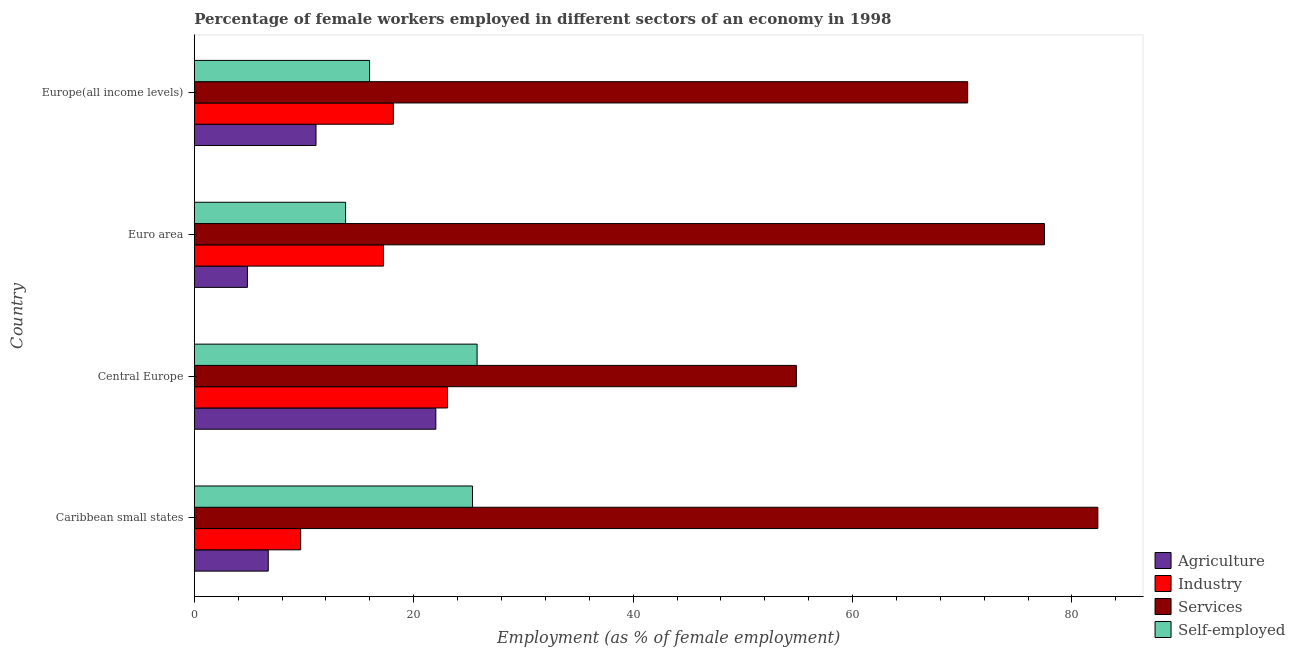How many groups of bars are there?
Provide a short and direct response. 4. How many bars are there on the 1st tick from the bottom?
Offer a very short reply. 4. What is the label of the 2nd group of bars from the top?
Your response must be concise. Euro area. What is the percentage of female workers in services in Euro area?
Your answer should be compact. 77.49. Across all countries, what is the maximum percentage of female workers in services?
Give a very brief answer. 82.36. Across all countries, what is the minimum percentage of female workers in services?
Your answer should be compact. 54.88. In which country was the percentage of female workers in agriculture maximum?
Offer a very short reply. Central Europe. What is the total percentage of female workers in agriculture in the graph?
Your response must be concise. 44.7. What is the difference between the percentage of female workers in industry in Central Europe and that in Europe(all income levels)?
Make the answer very short. 4.94. What is the difference between the percentage of female workers in agriculture in Euro area and the percentage of female workers in industry in Caribbean small states?
Your answer should be compact. -4.86. What is the average percentage of female workers in industry per country?
Your response must be concise. 17.04. What is the difference between the percentage of female workers in industry and percentage of female workers in agriculture in Euro area?
Offer a very short reply. 12.4. What is the ratio of the percentage of female workers in industry in Caribbean small states to that in Europe(all income levels)?
Provide a short and direct response. 0.54. What is the difference between the highest and the second highest percentage of self employed female workers?
Your answer should be compact. 0.42. What is the difference between the highest and the lowest percentage of female workers in agriculture?
Make the answer very short. 17.17. In how many countries, is the percentage of self employed female workers greater than the average percentage of self employed female workers taken over all countries?
Offer a very short reply. 2. Is it the case that in every country, the sum of the percentage of female workers in industry and percentage of self employed female workers is greater than the sum of percentage of female workers in agriculture and percentage of female workers in services?
Give a very brief answer. Yes. What does the 1st bar from the top in Europe(all income levels) represents?
Your response must be concise. Self-employed. What does the 1st bar from the bottom in Central Europe represents?
Give a very brief answer. Agriculture. How many bars are there?
Offer a very short reply. 16. Are the values on the major ticks of X-axis written in scientific E-notation?
Offer a very short reply. No. Where does the legend appear in the graph?
Your answer should be very brief. Bottom right. How many legend labels are there?
Give a very brief answer. 4. How are the legend labels stacked?
Offer a very short reply. Vertical. What is the title of the graph?
Ensure brevity in your answer.  Percentage of female workers employed in different sectors of an economy in 1998. Does "Insurance services" appear as one of the legend labels in the graph?
Ensure brevity in your answer.  No. What is the label or title of the X-axis?
Offer a very short reply. Employment (as % of female employment). What is the Employment (as % of female employment) of Agriculture in Caribbean small states?
Your answer should be very brief. 6.74. What is the Employment (as % of female employment) of Industry in Caribbean small states?
Your response must be concise. 9.7. What is the Employment (as % of female employment) in Services in Caribbean small states?
Provide a short and direct response. 82.36. What is the Employment (as % of female employment) in Self-employed in Caribbean small states?
Provide a short and direct response. 25.36. What is the Employment (as % of female employment) in Agriculture in Central Europe?
Keep it short and to the point. 22.02. What is the Employment (as % of female employment) in Industry in Central Europe?
Your answer should be very brief. 23.09. What is the Employment (as % of female employment) in Services in Central Europe?
Ensure brevity in your answer.  54.88. What is the Employment (as % of female employment) in Self-employed in Central Europe?
Make the answer very short. 25.78. What is the Employment (as % of female employment) of Agriculture in Euro area?
Your answer should be compact. 4.84. What is the Employment (as % of female employment) of Industry in Euro area?
Keep it short and to the point. 17.24. What is the Employment (as % of female employment) of Services in Euro area?
Offer a very short reply. 77.49. What is the Employment (as % of female employment) of Self-employed in Euro area?
Your answer should be compact. 13.79. What is the Employment (as % of female employment) in Agriculture in Europe(all income levels)?
Provide a short and direct response. 11.1. What is the Employment (as % of female employment) in Industry in Europe(all income levels)?
Your response must be concise. 18.14. What is the Employment (as % of female employment) of Services in Europe(all income levels)?
Offer a very short reply. 70.5. What is the Employment (as % of female employment) in Self-employed in Europe(all income levels)?
Offer a terse response. 15.98. Across all countries, what is the maximum Employment (as % of female employment) in Agriculture?
Ensure brevity in your answer.  22.02. Across all countries, what is the maximum Employment (as % of female employment) of Industry?
Your response must be concise. 23.09. Across all countries, what is the maximum Employment (as % of female employment) of Services?
Provide a short and direct response. 82.36. Across all countries, what is the maximum Employment (as % of female employment) of Self-employed?
Your answer should be very brief. 25.78. Across all countries, what is the minimum Employment (as % of female employment) of Agriculture?
Make the answer very short. 4.84. Across all countries, what is the minimum Employment (as % of female employment) in Industry?
Your answer should be compact. 9.7. Across all countries, what is the minimum Employment (as % of female employment) in Services?
Give a very brief answer. 54.88. Across all countries, what is the minimum Employment (as % of female employment) of Self-employed?
Ensure brevity in your answer.  13.79. What is the total Employment (as % of female employment) in Agriculture in the graph?
Your answer should be very brief. 44.7. What is the total Employment (as % of female employment) of Industry in the graph?
Ensure brevity in your answer.  68.17. What is the total Employment (as % of female employment) in Services in the graph?
Your response must be concise. 285.23. What is the total Employment (as % of female employment) in Self-employed in the graph?
Keep it short and to the point. 80.92. What is the difference between the Employment (as % of female employment) of Agriculture in Caribbean small states and that in Central Europe?
Keep it short and to the point. -15.27. What is the difference between the Employment (as % of female employment) in Industry in Caribbean small states and that in Central Europe?
Keep it short and to the point. -13.39. What is the difference between the Employment (as % of female employment) of Services in Caribbean small states and that in Central Europe?
Offer a very short reply. 27.48. What is the difference between the Employment (as % of female employment) in Self-employed in Caribbean small states and that in Central Europe?
Your answer should be very brief. -0.42. What is the difference between the Employment (as % of female employment) of Agriculture in Caribbean small states and that in Euro area?
Give a very brief answer. 1.9. What is the difference between the Employment (as % of female employment) of Industry in Caribbean small states and that in Euro area?
Make the answer very short. -7.54. What is the difference between the Employment (as % of female employment) of Services in Caribbean small states and that in Euro area?
Make the answer very short. 4.87. What is the difference between the Employment (as % of female employment) of Self-employed in Caribbean small states and that in Euro area?
Your answer should be very brief. 11.57. What is the difference between the Employment (as % of female employment) of Agriculture in Caribbean small states and that in Europe(all income levels)?
Offer a terse response. -4.35. What is the difference between the Employment (as % of female employment) in Industry in Caribbean small states and that in Europe(all income levels)?
Give a very brief answer. -8.44. What is the difference between the Employment (as % of female employment) in Services in Caribbean small states and that in Europe(all income levels)?
Give a very brief answer. 11.86. What is the difference between the Employment (as % of female employment) in Self-employed in Caribbean small states and that in Europe(all income levels)?
Keep it short and to the point. 9.38. What is the difference between the Employment (as % of female employment) of Agriculture in Central Europe and that in Euro area?
Give a very brief answer. 17.17. What is the difference between the Employment (as % of female employment) in Industry in Central Europe and that in Euro area?
Keep it short and to the point. 5.84. What is the difference between the Employment (as % of female employment) of Services in Central Europe and that in Euro area?
Provide a short and direct response. -22.61. What is the difference between the Employment (as % of female employment) in Self-employed in Central Europe and that in Euro area?
Provide a short and direct response. 11.99. What is the difference between the Employment (as % of female employment) in Agriculture in Central Europe and that in Europe(all income levels)?
Your response must be concise. 10.92. What is the difference between the Employment (as % of female employment) in Industry in Central Europe and that in Europe(all income levels)?
Keep it short and to the point. 4.94. What is the difference between the Employment (as % of female employment) of Services in Central Europe and that in Europe(all income levels)?
Offer a terse response. -15.62. What is the difference between the Employment (as % of female employment) of Self-employed in Central Europe and that in Europe(all income levels)?
Offer a very short reply. 9.8. What is the difference between the Employment (as % of female employment) of Agriculture in Euro area and that in Europe(all income levels)?
Make the answer very short. -6.25. What is the difference between the Employment (as % of female employment) in Industry in Euro area and that in Europe(all income levels)?
Make the answer very short. -0.9. What is the difference between the Employment (as % of female employment) in Services in Euro area and that in Europe(all income levels)?
Your answer should be very brief. 7. What is the difference between the Employment (as % of female employment) of Self-employed in Euro area and that in Europe(all income levels)?
Offer a terse response. -2.19. What is the difference between the Employment (as % of female employment) of Agriculture in Caribbean small states and the Employment (as % of female employment) of Industry in Central Europe?
Provide a short and direct response. -16.34. What is the difference between the Employment (as % of female employment) in Agriculture in Caribbean small states and the Employment (as % of female employment) in Services in Central Europe?
Your answer should be very brief. -48.14. What is the difference between the Employment (as % of female employment) in Agriculture in Caribbean small states and the Employment (as % of female employment) in Self-employed in Central Europe?
Ensure brevity in your answer.  -19.03. What is the difference between the Employment (as % of female employment) of Industry in Caribbean small states and the Employment (as % of female employment) of Services in Central Europe?
Give a very brief answer. -45.18. What is the difference between the Employment (as % of female employment) of Industry in Caribbean small states and the Employment (as % of female employment) of Self-employed in Central Europe?
Provide a succinct answer. -16.08. What is the difference between the Employment (as % of female employment) in Services in Caribbean small states and the Employment (as % of female employment) in Self-employed in Central Europe?
Keep it short and to the point. 56.58. What is the difference between the Employment (as % of female employment) in Agriculture in Caribbean small states and the Employment (as % of female employment) in Industry in Euro area?
Provide a short and direct response. -10.5. What is the difference between the Employment (as % of female employment) of Agriculture in Caribbean small states and the Employment (as % of female employment) of Services in Euro area?
Offer a very short reply. -70.75. What is the difference between the Employment (as % of female employment) in Agriculture in Caribbean small states and the Employment (as % of female employment) in Self-employed in Euro area?
Offer a very short reply. -7.05. What is the difference between the Employment (as % of female employment) of Industry in Caribbean small states and the Employment (as % of female employment) of Services in Euro area?
Offer a very short reply. -67.79. What is the difference between the Employment (as % of female employment) in Industry in Caribbean small states and the Employment (as % of female employment) in Self-employed in Euro area?
Offer a terse response. -4.09. What is the difference between the Employment (as % of female employment) of Services in Caribbean small states and the Employment (as % of female employment) of Self-employed in Euro area?
Offer a terse response. 68.57. What is the difference between the Employment (as % of female employment) of Agriculture in Caribbean small states and the Employment (as % of female employment) of Industry in Europe(all income levels)?
Ensure brevity in your answer.  -11.4. What is the difference between the Employment (as % of female employment) of Agriculture in Caribbean small states and the Employment (as % of female employment) of Services in Europe(all income levels)?
Offer a very short reply. -63.75. What is the difference between the Employment (as % of female employment) in Agriculture in Caribbean small states and the Employment (as % of female employment) in Self-employed in Europe(all income levels)?
Make the answer very short. -9.24. What is the difference between the Employment (as % of female employment) in Industry in Caribbean small states and the Employment (as % of female employment) in Services in Europe(all income levels)?
Ensure brevity in your answer.  -60.8. What is the difference between the Employment (as % of female employment) of Industry in Caribbean small states and the Employment (as % of female employment) of Self-employed in Europe(all income levels)?
Your response must be concise. -6.28. What is the difference between the Employment (as % of female employment) in Services in Caribbean small states and the Employment (as % of female employment) in Self-employed in Europe(all income levels)?
Ensure brevity in your answer.  66.38. What is the difference between the Employment (as % of female employment) in Agriculture in Central Europe and the Employment (as % of female employment) in Industry in Euro area?
Give a very brief answer. 4.77. What is the difference between the Employment (as % of female employment) in Agriculture in Central Europe and the Employment (as % of female employment) in Services in Euro area?
Provide a succinct answer. -55.48. What is the difference between the Employment (as % of female employment) in Agriculture in Central Europe and the Employment (as % of female employment) in Self-employed in Euro area?
Make the answer very short. 8.22. What is the difference between the Employment (as % of female employment) in Industry in Central Europe and the Employment (as % of female employment) in Services in Euro area?
Offer a very short reply. -54.41. What is the difference between the Employment (as % of female employment) in Industry in Central Europe and the Employment (as % of female employment) in Self-employed in Euro area?
Offer a terse response. 9.29. What is the difference between the Employment (as % of female employment) in Services in Central Europe and the Employment (as % of female employment) in Self-employed in Euro area?
Your response must be concise. 41.09. What is the difference between the Employment (as % of female employment) of Agriculture in Central Europe and the Employment (as % of female employment) of Industry in Europe(all income levels)?
Offer a very short reply. 3.87. What is the difference between the Employment (as % of female employment) in Agriculture in Central Europe and the Employment (as % of female employment) in Services in Europe(all income levels)?
Keep it short and to the point. -48.48. What is the difference between the Employment (as % of female employment) in Agriculture in Central Europe and the Employment (as % of female employment) in Self-employed in Europe(all income levels)?
Your answer should be very brief. 6.04. What is the difference between the Employment (as % of female employment) in Industry in Central Europe and the Employment (as % of female employment) in Services in Europe(all income levels)?
Keep it short and to the point. -47.41. What is the difference between the Employment (as % of female employment) in Industry in Central Europe and the Employment (as % of female employment) in Self-employed in Europe(all income levels)?
Give a very brief answer. 7.11. What is the difference between the Employment (as % of female employment) of Services in Central Europe and the Employment (as % of female employment) of Self-employed in Europe(all income levels)?
Ensure brevity in your answer.  38.9. What is the difference between the Employment (as % of female employment) of Agriculture in Euro area and the Employment (as % of female employment) of Industry in Europe(all income levels)?
Provide a succinct answer. -13.3. What is the difference between the Employment (as % of female employment) of Agriculture in Euro area and the Employment (as % of female employment) of Services in Europe(all income levels)?
Provide a succinct answer. -65.65. What is the difference between the Employment (as % of female employment) in Agriculture in Euro area and the Employment (as % of female employment) in Self-employed in Europe(all income levels)?
Make the answer very short. -11.14. What is the difference between the Employment (as % of female employment) of Industry in Euro area and the Employment (as % of female employment) of Services in Europe(all income levels)?
Ensure brevity in your answer.  -53.25. What is the difference between the Employment (as % of female employment) of Industry in Euro area and the Employment (as % of female employment) of Self-employed in Europe(all income levels)?
Keep it short and to the point. 1.26. What is the difference between the Employment (as % of female employment) in Services in Euro area and the Employment (as % of female employment) in Self-employed in Europe(all income levels)?
Give a very brief answer. 61.51. What is the average Employment (as % of female employment) of Agriculture per country?
Your answer should be compact. 11.18. What is the average Employment (as % of female employment) in Industry per country?
Offer a very short reply. 17.04. What is the average Employment (as % of female employment) of Services per country?
Ensure brevity in your answer.  71.31. What is the average Employment (as % of female employment) of Self-employed per country?
Make the answer very short. 20.23. What is the difference between the Employment (as % of female employment) of Agriculture and Employment (as % of female employment) of Industry in Caribbean small states?
Provide a succinct answer. -2.96. What is the difference between the Employment (as % of female employment) of Agriculture and Employment (as % of female employment) of Services in Caribbean small states?
Your response must be concise. -75.62. What is the difference between the Employment (as % of female employment) of Agriculture and Employment (as % of female employment) of Self-employed in Caribbean small states?
Your answer should be very brief. -18.62. What is the difference between the Employment (as % of female employment) in Industry and Employment (as % of female employment) in Services in Caribbean small states?
Keep it short and to the point. -72.66. What is the difference between the Employment (as % of female employment) in Industry and Employment (as % of female employment) in Self-employed in Caribbean small states?
Give a very brief answer. -15.66. What is the difference between the Employment (as % of female employment) in Services and Employment (as % of female employment) in Self-employed in Caribbean small states?
Your answer should be very brief. 57. What is the difference between the Employment (as % of female employment) in Agriculture and Employment (as % of female employment) in Industry in Central Europe?
Your answer should be very brief. -1.07. What is the difference between the Employment (as % of female employment) of Agriculture and Employment (as % of female employment) of Services in Central Europe?
Make the answer very short. -32.86. What is the difference between the Employment (as % of female employment) of Agriculture and Employment (as % of female employment) of Self-employed in Central Europe?
Your answer should be very brief. -3.76. What is the difference between the Employment (as % of female employment) of Industry and Employment (as % of female employment) of Services in Central Europe?
Offer a terse response. -31.79. What is the difference between the Employment (as % of female employment) of Industry and Employment (as % of female employment) of Self-employed in Central Europe?
Make the answer very short. -2.69. What is the difference between the Employment (as % of female employment) in Services and Employment (as % of female employment) in Self-employed in Central Europe?
Provide a succinct answer. 29.1. What is the difference between the Employment (as % of female employment) of Agriculture and Employment (as % of female employment) of Industry in Euro area?
Give a very brief answer. -12.4. What is the difference between the Employment (as % of female employment) in Agriculture and Employment (as % of female employment) in Services in Euro area?
Your response must be concise. -72.65. What is the difference between the Employment (as % of female employment) in Agriculture and Employment (as % of female employment) in Self-employed in Euro area?
Offer a terse response. -8.95. What is the difference between the Employment (as % of female employment) in Industry and Employment (as % of female employment) in Services in Euro area?
Offer a very short reply. -60.25. What is the difference between the Employment (as % of female employment) of Industry and Employment (as % of female employment) of Self-employed in Euro area?
Ensure brevity in your answer.  3.45. What is the difference between the Employment (as % of female employment) in Services and Employment (as % of female employment) in Self-employed in Euro area?
Provide a short and direct response. 63.7. What is the difference between the Employment (as % of female employment) of Agriculture and Employment (as % of female employment) of Industry in Europe(all income levels)?
Offer a terse response. -7.05. What is the difference between the Employment (as % of female employment) of Agriculture and Employment (as % of female employment) of Services in Europe(all income levels)?
Ensure brevity in your answer.  -59.4. What is the difference between the Employment (as % of female employment) of Agriculture and Employment (as % of female employment) of Self-employed in Europe(all income levels)?
Your answer should be compact. -4.88. What is the difference between the Employment (as % of female employment) in Industry and Employment (as % of female employment) in Services in Europe(all income levels)?
Make the answer very short. -52.35. What is the difference between the Employment (as % of female employment) in Industry and Employment (as % of female employment) in Self-employed in Europe(all income levels)?
Offer a terse response. 2.16. What is the difference between the Employment (as % of female employment) of Services and Employment (as % of female employment) of Self-employed in Europe(all income levels)?
Provide a succinct answer. 54.52. What is the ratio of the Employment (as % of female employment) of Agriculture in Caribbean small states to that in Central Europe?
Your answer should be compact. 0.31. What is the ratio of the Employment (as % of female employment) of Industry in Caribbean small states to that in Central Europe?
Give a very brief answer. 0.42. What is the ratio of the Employment (as % of female employment) in Services in Caribbean small states to that in Central Europe?
Provide a succinct answer. 1.5. What is the ratio of the Employment (as % of female employment) in Self-employed in Caribbean small states to that in Central Europe?
Ensure brevity in your answer.  0.98. What is the ratio of the Employment (as % of female employment) in Agriculture in Caribbean small states to that in Euro area?
Make the answer very short. 1.39. What is the ratio of the Employment (as % of female employment) in Industry in Caribbean small states to that in Euro area?
Offer a terse response. 0.56. What is the ratio of the Employment (as % of female employment) in Services in Caribbean small states to that in Euro area?
Give a very brief answer. 1.06. What is the ratio of the Employment (as % of female employment) of Self-employed in Caribbean small states to that in Euro area?
Provide a succinct answer. 1.84. What is the ratio of the Employment (as % of female employment) in Agriculture in Caribbean small states to that in Europe(all income levels)?
Provide a short and direct response. 0.61. What is the ratio of the Employment (as % of female employment) of Industry in Caribbean small states to that in Europe(all income levels)?
Offer a terse response. 0.53. What is the ratio of the Employment (as % of female employment) of Services in Caribbean small states to that in Europe(all income levels)?
Keep it short and to the point. 1.17. What is the ratio of the Employment (as % of female employment) of Self-employed in Caribbean small states to that in Europe(all income levels)?
Keep it short and to the point. 1.59. What is the ratio of the Employment (as % of female employment) of Agriculture in Central Europe to that in Euro area?
Ensure brevity in your answer.  4.54. What is the ratio of the Employment (as % of female employment) in Industry in Central Europe to that in Euro area?
Provide a short and direct response. 1.34. What is the ratio of the Employment (as % of female employment) of Services in Central Europe to that in Euro area?
Offer a very short reply. 0.71. What is the ratio of the Employment (as % of female employment) in Self-employed in Central Europe to that in Euro area?
Provide a short and direct response. 1.87. What is the ratio of the Employment (as % of female employment) in Agriculture in Central Europe to that in Europe(all income levels)?
Provide a short and direct response. 1.98. What is the ratio of the Employment (as % of female employment) of Industry in Central Europe to that in Europe(all income levels)?
Provide a succinct answer. 1.27. What is the ratio of the Employment (as % of female employment) of Services in Central Europe to that in Europe(all income levels)?
Offer a very short reply. 0.78. What is the ratio of the Employment (as % of female employment) in Self-employed in Central Europe to that in Europe(all income levels)?
Provide a short and direct response. 1.61. What is the ratio of the Employment (as % of female employment) in Agriculture in Euro area to that in Europe(all income levels)?
Your answer should be very brief. 0.44. What is the ratio of the Employment (as % of female employment) in Industry in Euro area to that in Europe(all income levels)?
Provide a short and direct response. 0.95. What is the ratio of the Employment (as % of female employment) of Services in Euro area to that in Europe(all income levels)?
Your answer should be compact. 1.1. What is the ratio of the Employment (as % of female employment) of Self-employed in Euro area to that in Europe(all income levels)?
Keep it short and to the point. 0.86. What is the difference between the highest and the second highest Employment (as % of female employment) in Agriculture?
Your response must be concise. 10.92. What is the difference between the highest and the second highest Employment (as % of female employment) of Industry?
Your answer should be very brief. 4.94. What is the difference between the highest and the second highest Employment (as % of female employment) in Services?
Offer a terse response. 4.87. What is the difference between the highest and the second highest Employment (as % of female employment) in Self-employed?
Provide a short and direct response. 0.42. What is the difference between the highest and the lowest Employment (as % of female employment) in Agriculture?
Provide a short and direct response. 17.17. What is the difference between the highest and the lowest Employment (as % of female employment) of Industry?
Give a very brief answer. 13.39. What is the difference between the highest and the lowest Employment (as % of female employment) in Services?
Your answer should be very brief. 27.48. What is the difference between the highest and the lowest Employment (as % of female employment) of Self-employed?
Your response must be concise. 11.99. 